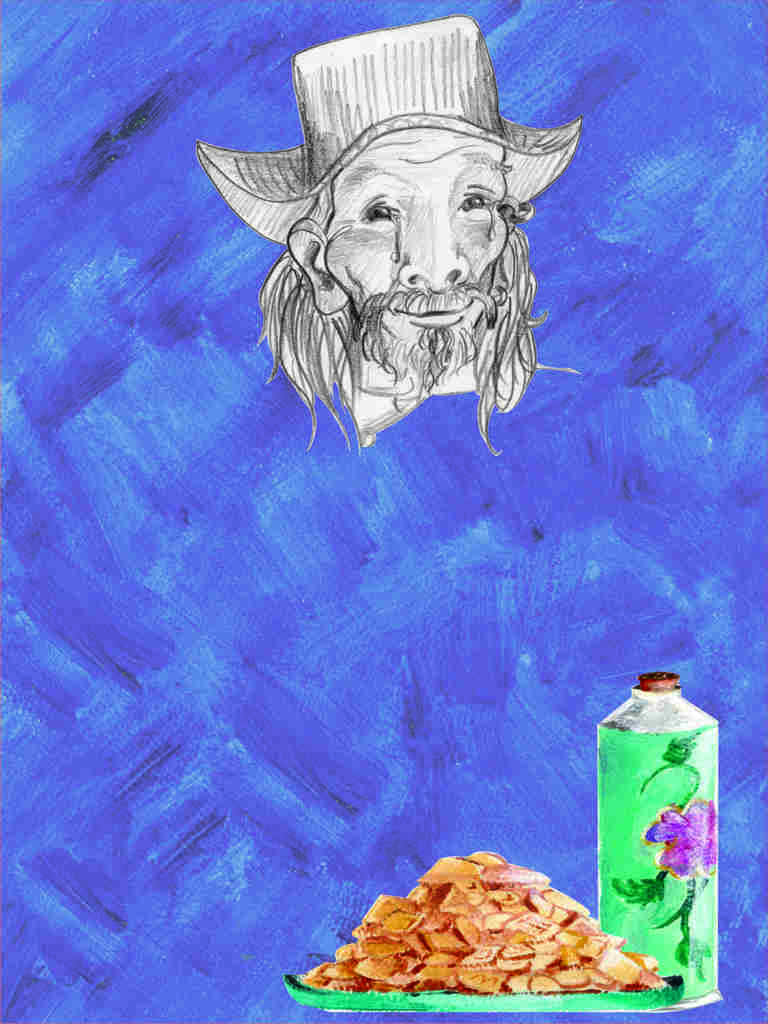What is the main subject of the painting? The painting depicts a person's face. What accessory is the person wearing in the painting? The person is wearing a hat. What type of food can be seen in the painting? There is food in the painting. What beverage container is present in the painting? There is a beverage bottle in the painting. How does the artist maintain balance while painting the person's face? The artist's balance while painting is not depicted in the image, as it is a static painting. What type of ink was used to create the painting? The type of ink used to create the painting is not mentioned in the provided facts. 